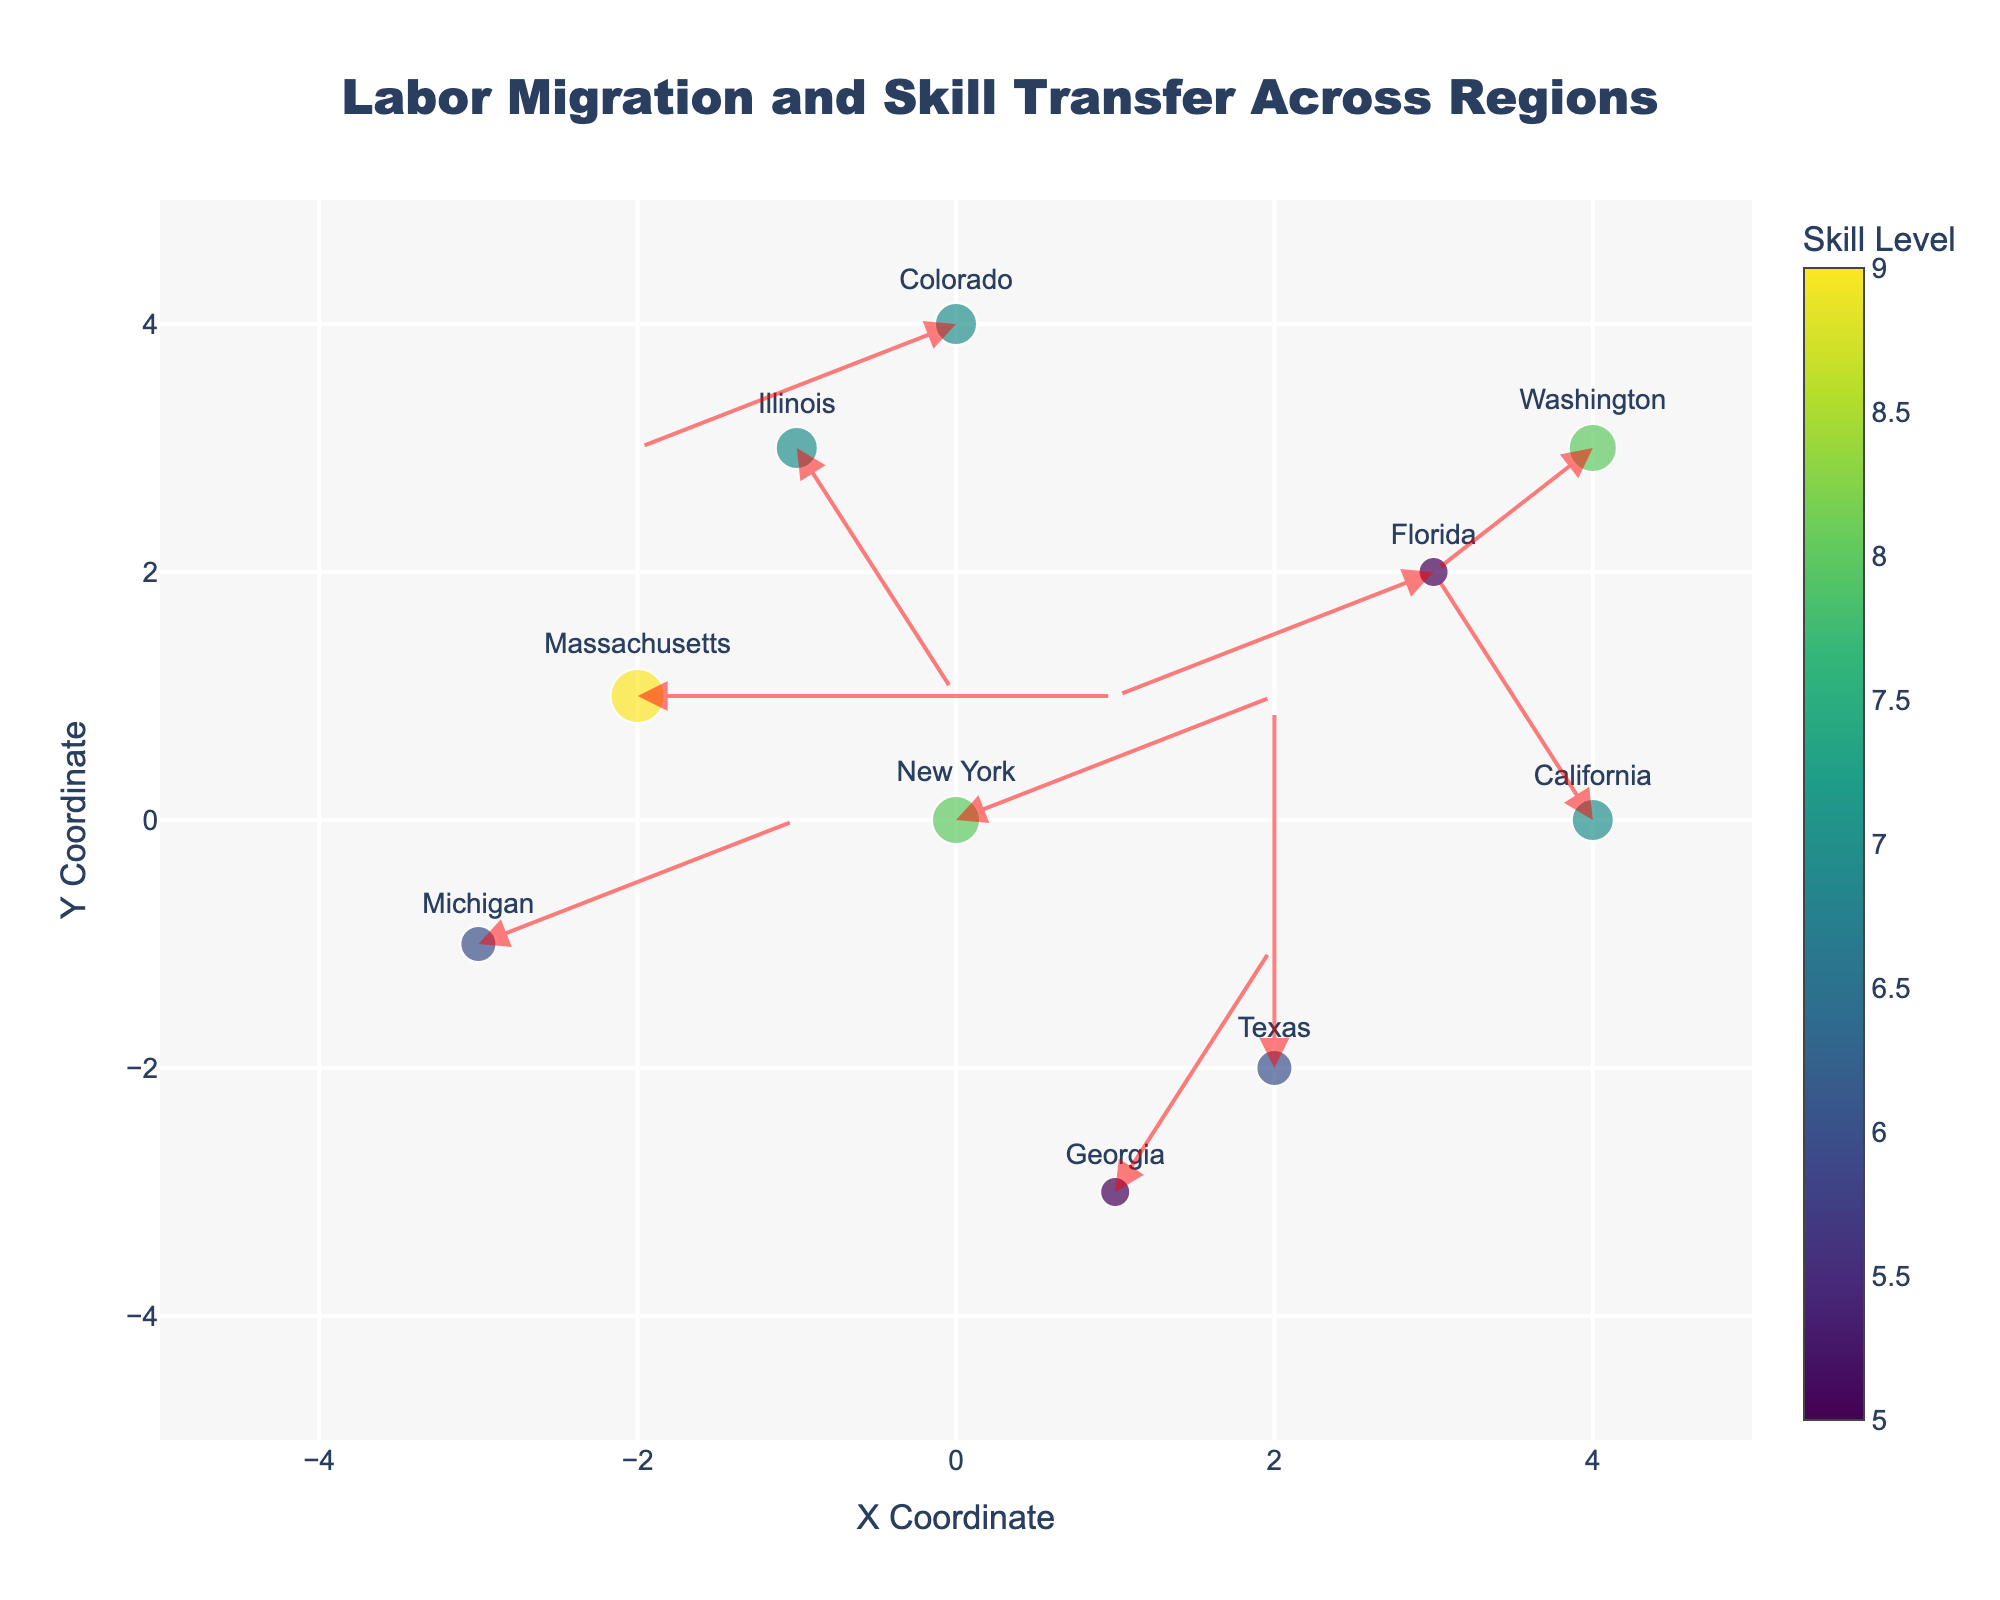Which region has the highest skill level? The color scale represents skill level, and the deepest color correlates to the highest skill. Massachusetts shows the deepest color with a skill level of 9.
Answer: Massachusetts What is the direction of migration from New York? The arrow from New York points to the right and slightly upward, corresponding to the U and V components (2, 1), indicating northeastward movement.
Answer: Northeast How many regions have a skill level of 7? By examining the color bar and matching it to the points, we identify California, Illinois, and Colorado as having a skill level of 7.
Answer: Three Which region has the longest migration arrow? By visually assessing the lengths of the arrows, Florida's arrow appears the longest, indicating it has the highest combined movement in both directions.
Answer: Florida Which two regions have no horizontal migration? The horizontal component (U) for Texas and Massachusetts is 0, meaning no horizontal migration occurs for these regions.
Answer: Texas and Massachusetts What is the average skill level of the regions located at negative Y coordinates? Regions at negative Y coordinates are Texas, Michigan, and Georgia, with skill levels of 6, 6, and 5 respectively. The average is calculated as (6 + 6 + 5)/3 = 5.67.
Answer: 5.67 How does the skill level of Washington compare to New York? Washington has a skill level of 8, identical to New York, as shown by the color intensity on the plot.
Answer: Equal Which region's labor migration results in a downward movement? The vertical component (V) for Illinois, who moves from y=3 to y=1, and Florida, who moves from y=2 to y=1, indicates both regions experience downward movement.
Answer: Illinois and Florida Is there a region that shows no total migration (both horizontal and vertical components are zero)? By examining the arrows, all regions have at least one non-zero component, indicating there is no region with zero total migration.
Answer: No 